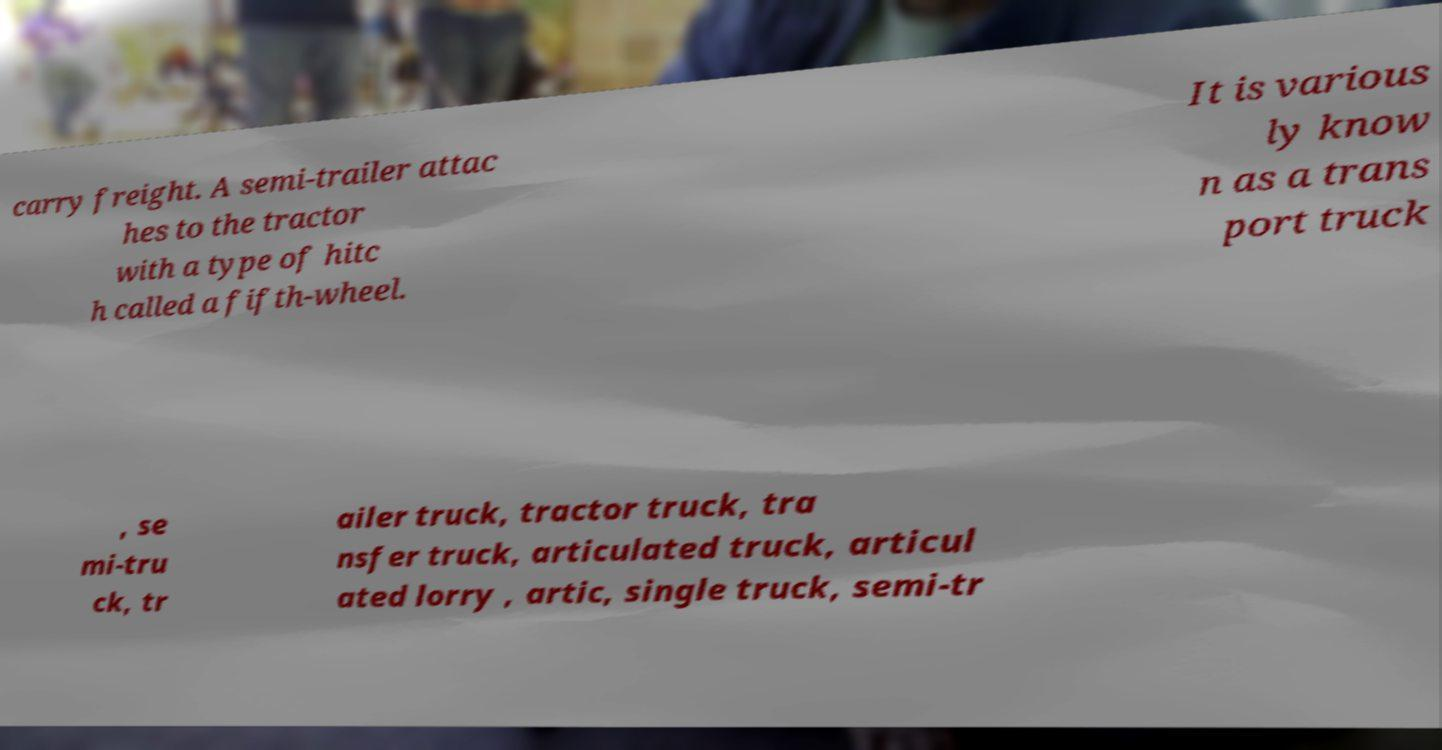There's text embedded in this image that I need extracted. Can you transcribe it verbatim? carry freight. A semi-trailer attac hes to the tractor with a type of hitc h called a fifth-wheel. It is various ly know n as a trans port truck , se mi-tru ck, tr ailer truck, tractor truck, tra nsfer truck, articulated truck, articul ated lorry , artic, single truck, semi-tr 